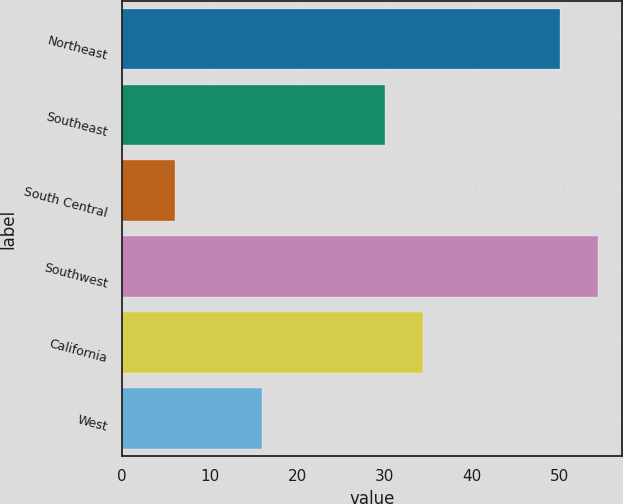Convert chart to OTSL. <chart><loc_0><loc_0><loc_500><loc_500><bar_chart><fcel>Northeast<fcel>Southeast<fcel>South Central<fcel>Southwest<fcel>California<fcel>West<nl><fcel>50<fcel>30<fcel>6<fcel>54.4<fcel>34.4<fcel>16<nl></chart> 